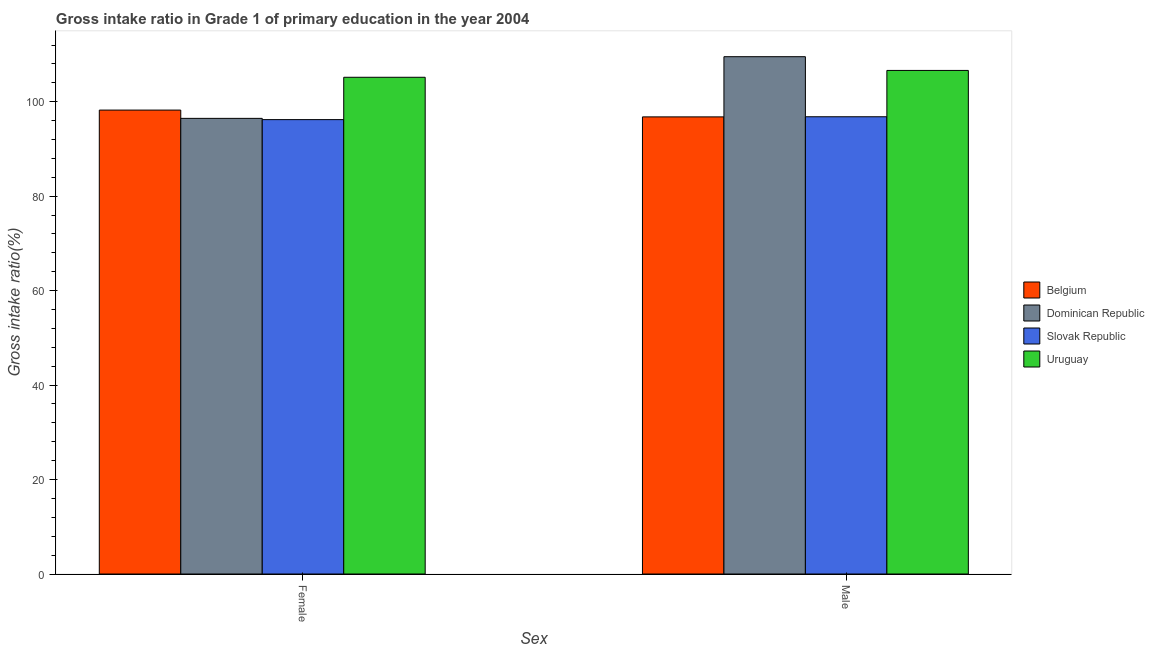How many different coloured bars are there?
Your answer should be very brief. 4. How many bars are there on the 1st tick from the right?
Give a very brief answer. 4. What is the gross intake ratio(male) in Belgium?
Offer a very short reply. 96.78. Across all countries, what is the maximum gross intake ratio(female)?
Your response must be concise. 105.17. Across all countries, what is the minimum gross intake ratio(male)?
Your answer should be compact. 96.78. In which country was the gross intake ratio(male) maximum?
Give a very brief answer. Dominican Republic. In which country was the gross intake ratio(male) minimum?
Offer a terse response. Belgium. What is the total gross intake ratio(female) in the graph?
Your response must be concise. 396.07. What is the difference between the gross intake ratio(male) in Slovak Republic and that in Dominican Republic?
Offer a very short reply. -12.72. What is the difference between the gross intake ratio(male) in Belgium and the gross intake ratio(female) in Uruguay?
Provide a short and direct response. -8.39. What is the average gross intake ratio(female) per country?
Keep it short and to the point. 99.02. What is the difference between the gross intake ratio(female) and gross intake ratio(male) in Slovak Republic?
Keep it short and to the point. -0.61. What is the ratio of the gross intake ratio(male) in Dominican Republic to that in Uruguay?
Your answer should be very brief. 1.03. What does the 2nd bar from the left in Male represents?
Keep it short and to the point. Dominican Republic. What does the 4th bar from the right in Female represents?
Give a very brief answer. Belgium. Are all the bars in the graph horizontal?
Keep it short and to the point. No. What is the difference between two consecutive major ticks on the Y-axis?
Your answer should be compact. 20. Does the graph contain any zero values?
Keep it short and to the point. No. How many legend labels are there?
Provide a short and direct response. 4. How are the legend labels stacked?
Make the answer very short. Vertical. What is the title of the graph?
Give a very brief answer. Gross intake ratio in Grade 1 of primary education in the year 2004. Does "Other small states" appear as one of the legend labels in the graph?
Ensure brevity in your answer.  No. What is the label or title of the X-axis?
Provide a short and direct response. Sex. What is the label or title of the Y-axis?
Offer a terse response. Gross intake ratio(%). What is the Gross intake ratio(%) of Belgium in Female?
Provide a succinct answer. 98.22. What is the Gross intake ratio(%) of Dominican Republic in Female?
Give a very brief answer. 96.47. What is the Gross intake ratio(%) in Slovak Republic in Female?
Offer a terse response. 96.2. What is the Gross intake ratio(%) of Uruguay in Female?
Offer a very short reply. 105.17. What is the Gross intake ratio(%) of Belgium in Male?
Keep it short and to the point. 96.78. What is the Gross intake ratio(%) in Dominican Republic in Male?
Offer a very short reply. 109.53. What is the Gross intake ratio(%) in Slovak Republic in Male?
Make the answer very short. 96.81. What is the Gross intake ratio(%) in Uruguay in Male?
Your answer should be compact. 106.62. Across all Sex, what is the maximum Gross intake ratio(%) of Belgium?
Your answer should be very brief. 98.22. Across all Sex, what is the maximum Gross intake ratio(%) in Dominican Republic?
Ensure brevity in your answer.  109.53. Across all Sex, what is the maximum Gross intake ratio(%) in Slovak Republic?
Make the answer very short. 96.81. Across all Sex, what is the maximum Gross intake ratio(%) in Uruguay?
Your answer should be compact. 106.62. Across all Sex, what is the minimum Gross intake ratio(%) of Belgium?
Ensure brevity in your answer.  96.78. Across all Sex, what is the minimum Gross intake ratio(%) in Dominican Republic?
Make the answer very short. 96.47. Across all Sex, what is the minimum Gross intake ratio(%) in Slovak Republic?
Ensure brevity in your answer.  96.2. Across all Sex, what is the minimum Gross intake ratio(%) of Uruguay?
Offer a terse response. 105.17. What is the total Gross intake ratio(%) of Belgium in the graph?
Give a very brief answer. 195.01. What is the total Gross intake ratio(%) in Dominican Republic in the graph?
Your answer should be very brief. 206. What is the total Gross intake ratio(%) of Slovak Republic in the graph?
Make the answer very short. 193.01. What is the total Gross intake ratio(%) of Uruguay in the graph?
Provide a succinct answer. 211.79. What is the difference between the Gross intake ratio(%) of Belgium in Female and that in Male?
Your answer should be compact. 1.44. What is the difference between the Gross intake ratio(%) in Dominican Republic in Female and that in Male?
Your answer should be very brief. -13.06. What is the difference between the Gross intake ratio(%) in Slovak Republic in Female and that in Male?
Provide a succinct answer. -0.61. What is the difference between the Gross intake ratio(%) of Uruguay in Female and that in Male?
Keep it short and to the point. -1.45. What is the difference between the Gross intake ratio(%) of Belgium in Female and the Gross intake ratio(%) of Dominican Republic in Male?
Provide a succinct answer. -11.3. What is the difference between the Gross intake ratio(%) of Belgium in Female and the Gross intake ratio(%) of Slovak Republic in Male?
Your answer should be very brief. 1.41. What is the difference between the Gross intake ratio(%) in Belgium in Female and the Gross intake ratio(%) in Uruguay in Male?
Provide a succinct answer. -8.39. What is the difference between the Gross intake ratio(%) in Dominican Republic in Female and the Gross intake ratio(%) in Slovak Republic in Male?
Your answer should be compact. -0.34. What is the difference between the Gross intake ratio(%) in Dominican Republic in Female and the Gross intake ratio(%) in Uruguay in Male?
Your response must be concise. -10.15. What is the difference between the Gross intake ratio(%) in Slovak Republic in Female and the Gross intake ratio(%) in Uruguay in Male?
Make the answer very short. -10.41. What is the average Gross intake ratio(%) of Belgium per Sex?
Give a very brief answer. 97.5. What is the average Gross intake ratio(%) of Dominican Republic per Sex?
Give a very brief answer. 103. What is the average Gross intake ratio(%) in Slovak Republic per Sex?
Give a very brief answer. 96.51. What is the average Gross intake ratio(%) of Uruguay per Sex?
Provide a succinct answer. 105.89. What is the difference between the Gross intake ratio(%) of Belgium and Gross intake ratio(%) of Dominican Republic in Female?
Make the answer very short. 1.75. What is the difference between the Gross intake ratio(%) in Belgium and Gross intake ratio(%) in Slovak Republic in Female?
Give a very brief answer. 2.02. What is the difference between the Gross intake ratio(%) in Belgium and Gross intake ratio(%) in Uruguay in Female?
Your response must be concise. -6.95. What is the difference between the Gross intake ratio(%) of Dominican Republic and Gross intake ratio(%) of Slovak Republic in Female?
Your answer should be compact. 0.27. What is the difference between the Gross intake ratio(%) in Dominican Republic and Gross intake ratio(%) in Uruguay in Female?
Your response must be concise. -8.7. What is the difference between the Gross intake ratio(%) of Slovak Republic and Gross intake ratio(%) of Uruguay in Female?
Offer a very short reply. -8.96. What is the difference between the Gross intake ratio(%) in Belgium and Gross intake ratio(%) in Dominican Republic in Male?
Your answer should be compact. -12.74. What is the difference between the Gross intake ratio(%) of Belgium and Gross intake ratio(%) of Slovak Republic in Male?
Give a very brief answer. -0.03. What is the difference between the Gross intake ratio(%) of Belgium and Gross intake ratio(%) of Uruguay in Male?
Your answer should be compact. -9.83. What is the difference between the Gross intake ratio(%) of Dominican Republic and Gross intake ratio(%) of Slovak Republic in Male?
Your answer should be very brief. 12.72. What is the difference between the Gross intake ratio(%) of Dominican Republic and Gross intake ratio(%) of Uruguay in Male?
Make the answer very short. 2.91. What is the difference between the Gross intake ratio(%) in Slovak Republic and Gross intake ratio(%) in Uruguay in Male?
Provide a succinct answer. -9.81. What is the ratio of the Gross intake ratio(%) of Belgium in Female to that in Male?
Provide a succinct answer. 1.01. What is the ratio of the Gross intake ratio(%) in Dominican Republic in Female to that in Male?
Offer a terse response. 0.88. What is the ratio of the Gross intake ratio(%) in Slovak Republic in Female to that in Male?
Your answer should be very brief. 0.99. What is the ratio of the Gross intake ratio(%) in Uruguay in Female to that in Male?
Offer a terse response. 0.99. What is the difference between the highest and the second highest Gross intake ratio(%) of Belgium?
Provide a succinct answer. 1.44. What is the difference between the highest and the second highest Gross intake ratio(%) in Dominican Republic?
Offer a very short reply. 13.06. What is the difference between the highest and the second highest Gross intake ratio(%) in Slovak Republic?
Keep it short and to the point. 0.61. What is the difference between the highest and the second highest Gross intake ratio(%) of Uruguay?
Keep it short and to the point. 1.45. What is the difference between the highest and the lowest Gross intake ratio(%) in Belgium?
Give a very brief answer. 1.44. What is the difference between the highest and the lowest Gross intake ratio(%) in Dominican Republic?
Offer a very short reply. 13.06. What is the difference between the highest and the lowest Gross intake ratio(%) of Slovak Republic?
Your answer should be compact. 0.61. What is the difference between the highest and the lowest Gross intake ratio(%) of Uruguay?
Keep it short and to the point. 1.45. 